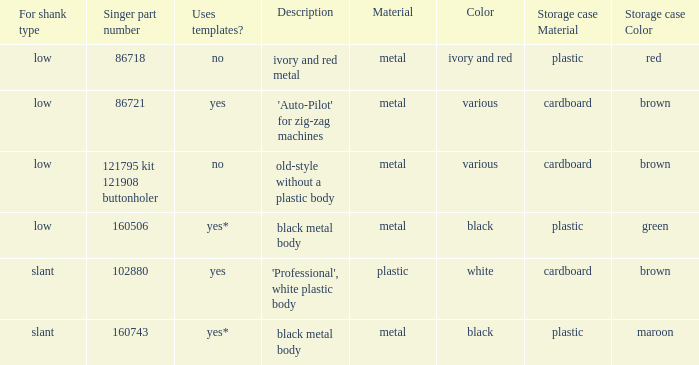What are all the different descriptions for the buttonholer with cardboard box for storage and a low shank type? 'Auto-Pilot' for zig-zag machines, old-style without a plastic body. 